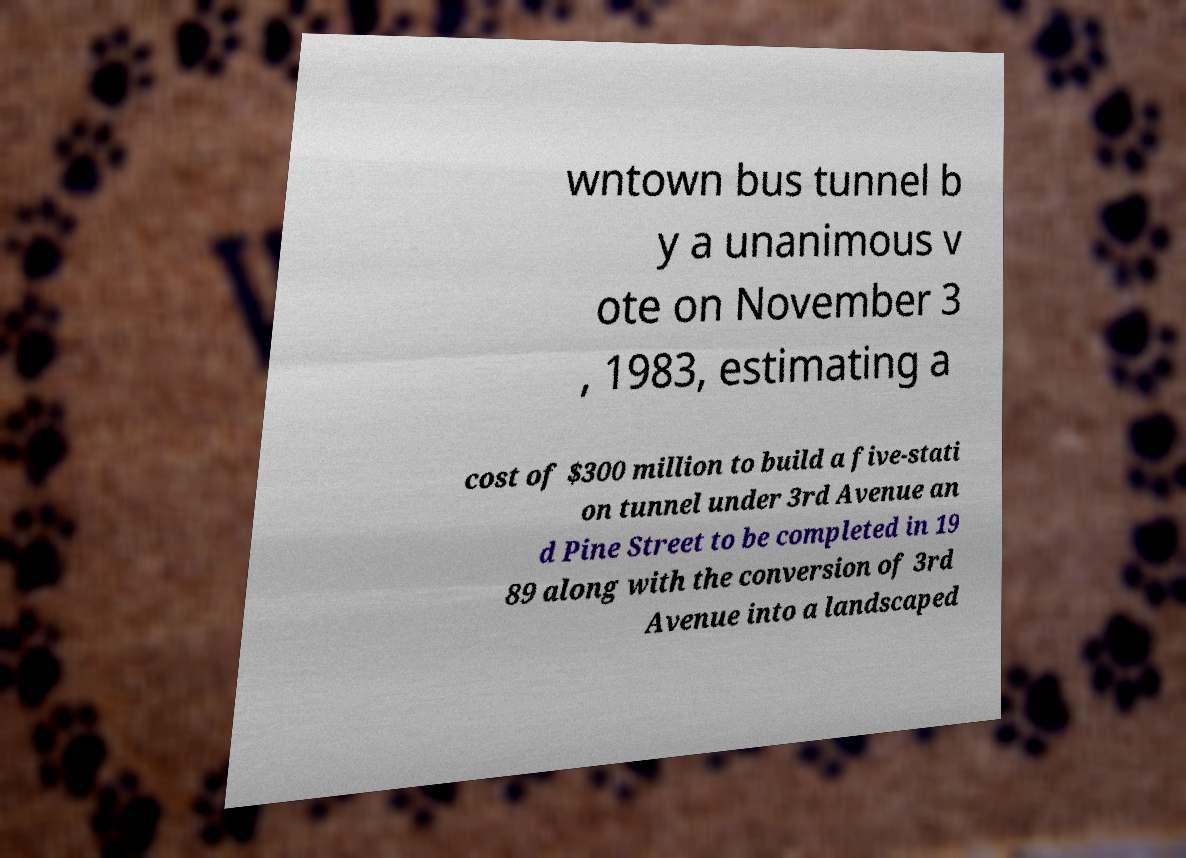I need the written content from this picture converted into text. Can you do that? wntown bus tunnel b y a unanimous v ote on November 3 , 1983, estimating a cost of $300 million to build a five-stati on tunnel under 3rd Avenue an d Pine Street to be completed in 19 89 along with the conversion of 3rd Avenue into a landscaped 